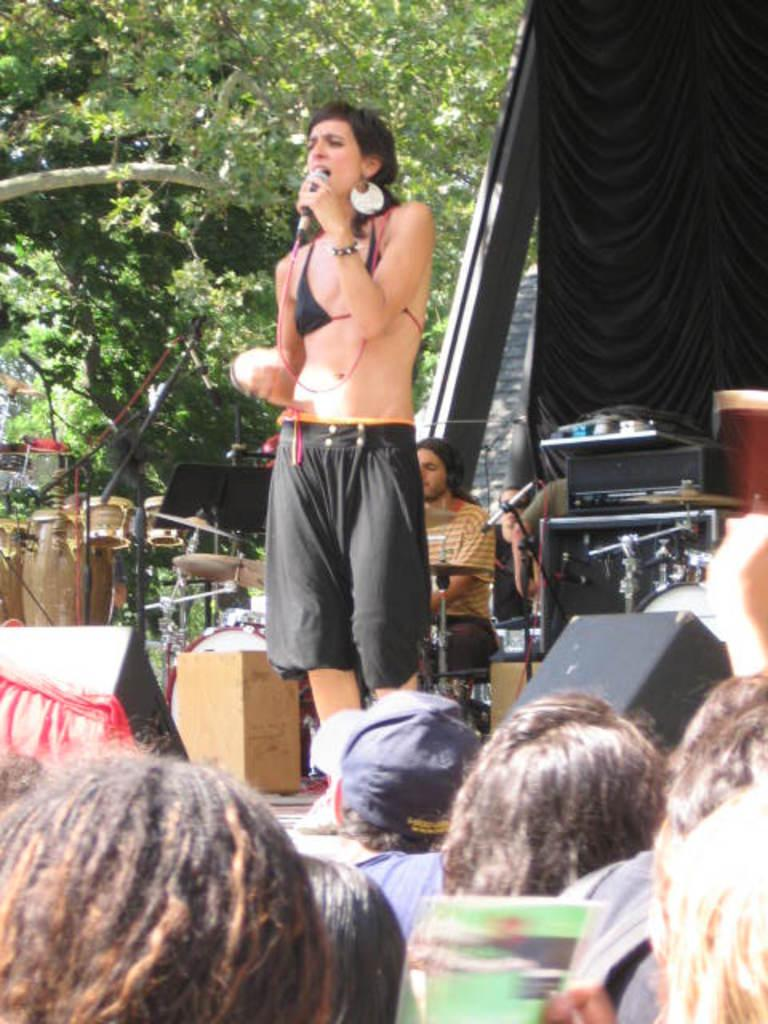What is the woman in the image doing? The woman is standing in the image and holding a microphone. What might the woman be using the microphone for? The woman might be using the microphone for speaking or singing. What other objects are present in the image? There are musical instruments in the image. How many people are surrounding the woman? People are surrounding the woman, but the exact number is not specified. What can be seen in the background of the image? There is a tree visible in the background. What type of bells can be heard ringing in the image? There are no bells present in the image, and therefore no sound can be heard. 